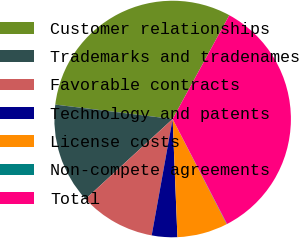<chart> <loc_0><loc_0><loc_500><loc_500><pie_chart><fcel>Customer relationships<fcel>Trademarks and tradenames<fcel>Favorable contracts<fcel>Technology and patents<fcel>License costs<fcel>Non-compete agreements<fcel>Total<nl><fcel>31.01%<fcel>13.77%<fcel>10.34%<fcel>3.48%<fcel>6.91%<fcel>0.05%<fcel>34.44%<nl></chart> 